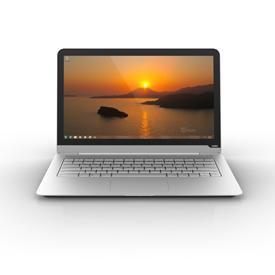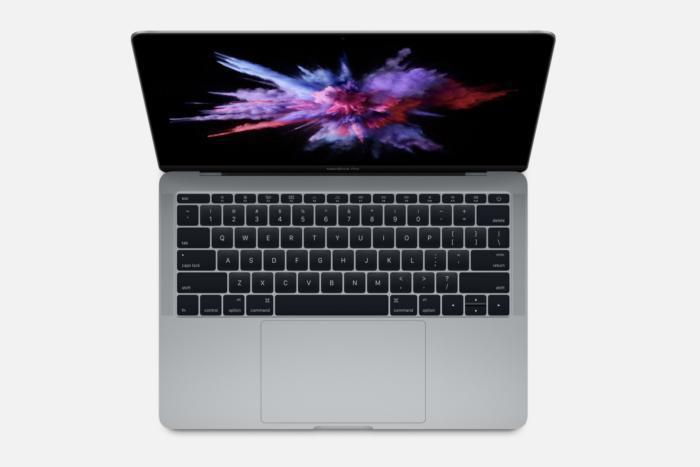The first image is the image on the left, the second image is the image on the right. Given the left and right images, does the statement "The left image shows a neat stack of at least three white laptop-type devices." hold true? Answer yes or no. No. The first image is the image on the left, the second image is the image on the right. Analyze the images presented: Is the assertion "In the image to the right, several electronic objects are stacked on top of each other." valid? Answer yes or no. No. 